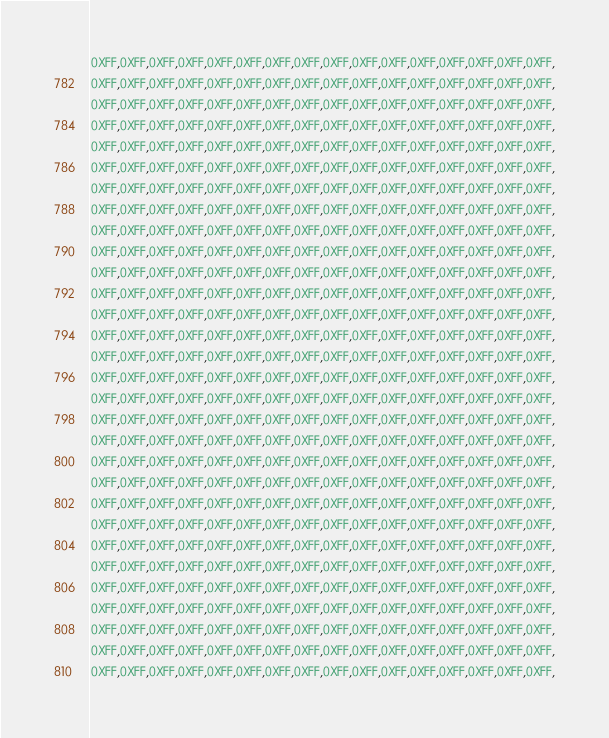<code> <loc_0><loc_0><loc_500><loc_500><_C_>0XFF,0XFF,0XFF,0XFF,0XFF,0XFF,0XFF,0XFF,0XFF,0XFF,0XFF,0XFF,0XFF,0XFF,0XFF,0XFF,
0XFF,0XFF,0XFF,0XFF,0XFF,0XFF,0XFF,0XFF,0XFF,0XFF,0XFF,0XFF,0XFF,0XFF,0XFF,0XFF,
0XFF,0XFF,0XFF,0XFF,0XFF,0XFF,0XFF,0XFF,0XFF,0XFF,0XFF,0XFF,0XFF,0XFF,0XFF,0XFF,
0XFF,0XFF,0XFF,0XFF,0XFF,0XFF,0XFF,0XFF,0XFF,0XFF,0XFF,0XFF,0XFF,0XFF,0XFF,0XFF,
0XFF,0XFF,0XFF,0XFF,0XFF,0XFF,0XFF,0XFF,0XFF,0XFF,0XFF,0XFF,0XFF,0XFF,0XFF,0XFF,
0XFF,0XFF,0XFF,0XFF,0XFF,0XFF,0XFF,0XFF,0XFF,0XFF,0XFF,0XFF,0XFF,0XFF,0XFF,0XFF,
0XFF,0XFF,0XFF,0XFF,0XFF,0XFF,0XFF,0XFF,0XFF,0XFF,0XFF,0XFF,0XFF,0XFF,0XFF,0XFF,
0XFF,0XFF,0XFF,0XFF,0XFF,0XFF,0XFF,0XFF,0XFF,0XFF,0XFF,0XFF,0XFF,0XFF,0XFF,0XFF,
0XFF,0XFF,0XFF,0XFF,0XFF,0XFF,0XFF,0XFF,0XFF,0XFF,0XFF,0XFF,0XFF,0XFF,0XFF,0XFF,
0XFF,0XFF,0XFF,0XFF,0XFF,0XFF,0XFF,0XFF,0XFF,0XFF,0XFF,0XFF,0XFF,0XFF,0XFF,0XFF,
0XFF,0XFF,0XFF,0XFF,0XFF,0XFF,0XFF,0XFF,0XFF,0XFF,0XFF,0XFF,0XFF,0XFF,0XFF,0XFF,
0XFF,0XFF,0XFF,0XFF,0XFF,0XFF,0XFF,0XFF,0XFF,0XFF,0XFF,0XFF,0XFF,0XFF,0XFF,0XFF,
0XFF,0XFF,0XFF,0XFF,0XFF,0XFF,0XFF,0XFF,0XFF,0XFF,0XFF,0XFF,0XFF,0XFF,0XFF,0XFF,
0XFF,0XFF,0XFF,0XFF,0XFF,0XFF,0XFF,0XFF,0XFF,0XFF,0XFF,0XFF,0XFF,0XFF,0XFF,0XFF,
0XFF,0XFF,0XFF,0XFF,0XFF,0XFF,0XFF,0XFF,0XFF,0XFF,0XFF,0XFF,0XFF,0XFF,0XFF,0XFF,
0XFF,0XFF,0XFF,0XFF,0XFF,0XFF,0XFF,0XFF,0XFF,0XFF,0XFF,0XFF,0XFF,0XFF,0XFF,0XFF,
0XFF,0XFF,0XFF,0XFF,0XFF,0XFF,0XFF,0XFF,0XFF,0XFF,0XFF,0XFF,0XFF,0XFF,0XFF,0XFF,
0XFF,0XFF,0XFF,0XFF,0XFF,0XFF,0XFF,0XFF,0XFF,0XFF,0XFF,0XFF,0XFF,0XFF,0XFF,0XFF,
0XFF,0XFF,0XFF,0XFF,0XFF,0XFF,0XFF,0XFF,0XFF,0XFF,0XFF,0XFF,0XFF,0XFF,0XFF,0XFF,
0XFF,0XFF,0XFF,0XFF,0XFF,0XFF,0XFF,0XFF,0XFF,0XFF,0XFF,0XFF,0XFF,0XFF,0XFF,0XFF,
0XFF,0XFF,0XFF,0XFF,0XFF,0XFF,0XFF,0XFF,0XFF,0XFF,0XFF,0XFF,0XFF,0XFF,0XFF,0XFF,
0XFF,0XFF,0XFF,0XFF,0XFF,0XFF,0XFF,0XFF,0XFF,0XFF,0XFF,0XFF,0XFF,0XFF,0XFF,0XFF,
0XFF,0XFF,0XFF,0XFF,0XFF,0XFF,0XFF,0XFF,0XFF,0XFF,0XFF,0XFF,0XFF,0XFF,0XFF,0XFF,
0XFF,0XFF,0XFF,0XFF,0XFF,0XFF,0XFF,0XFF,0XFF,0XFF,0XFF,0XFF,0XFF,0XFF,0XFF,0XFF,
0XFF,0XFF,0XFF,0XFF,0XFF,0XFF,0XFF,0XFF,0XFF,0XFF,0XFF,0XFF,0XFF,0XFF,0XFF,0XFF,
0XFF,0XFF,0XFF,0XFF,0XFF,0XFF,0XFF,0XFF,0XFF,0XFF,0XFF,0XFF,0XFF,0XFF,0XFF,0XFF,
0XFF,0XFF,0XFF,0XFF,0XFF,0XFF,0XFF,0XFF,0XFF,0XFF,0XFF,0XFF,0XFF,0XFF,0XFF,0XFF,
0XFF,0XFF,0XFF,0XFF,0XFF,0XFF,0XFF,0XFF,0XFF,0XFF,0XFF,0XFF,0XFF,0XFF,0XFF,0XFF,
0XFF,0XFF,0XFF,0XFF,0XFF,0XFF,0XFF,0XFF,0XFF,0XFF,0XFF,0XFF,0XFF,0XFF,0XFF,0XFF,
0XFF,0XFF,0XFF,0XFF,0XFF,0XFF,0XFF,0XFF,0XFF,0XFF,0XFF,0XFF,0XFF,0XFF,0XFF,0XFF,</code> 